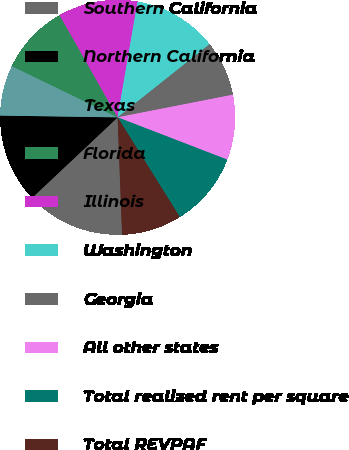Convert chart to OTSL. <chart><loc_0><loc_0><loc_500><loc_500><pie_chart><fcel>Southern California<fcel>Northern California<fcel>Texas<fcel>Florida<fcel>Illinois<fcel>Washington<fcel>Georgia<fcel>All other states<fcel>Total realized rent per square<fcel>Total REVPAF<nl><fcel>13.59%<fcel>12.25%<fcel>6.94%<fcel>9.6%<fcel>10.93%<fcel>11.59%<fcel>7.61%<fcel>8.94%<fcel>10.26%<fcel>8.27%<nl></chart> 